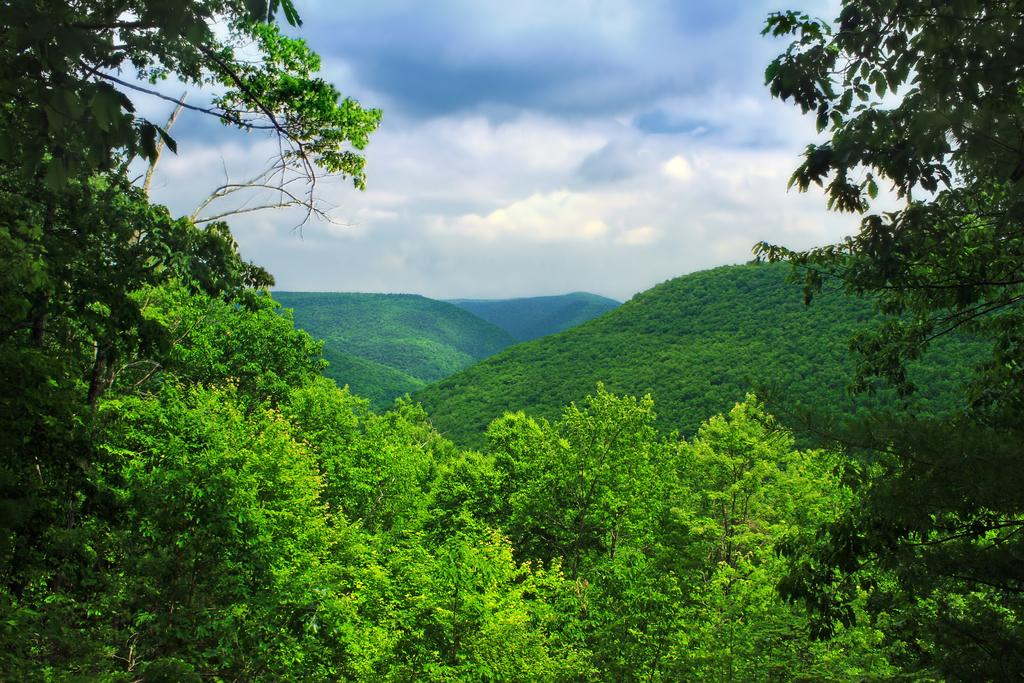What type of natural elements can be seen in the image? There are trees and hills in the image. What is visible at the top of the image? The sky is visible at the top of the image. What can be observed in the sky? Clouds are present in the sky. Can you see the carpenter working on a plate in the image? There is no carpenter or plate present in the image. Is there a rabbit hiding among the trees in the image? There is no rabbit visible in the image; only trees and hills are present. 